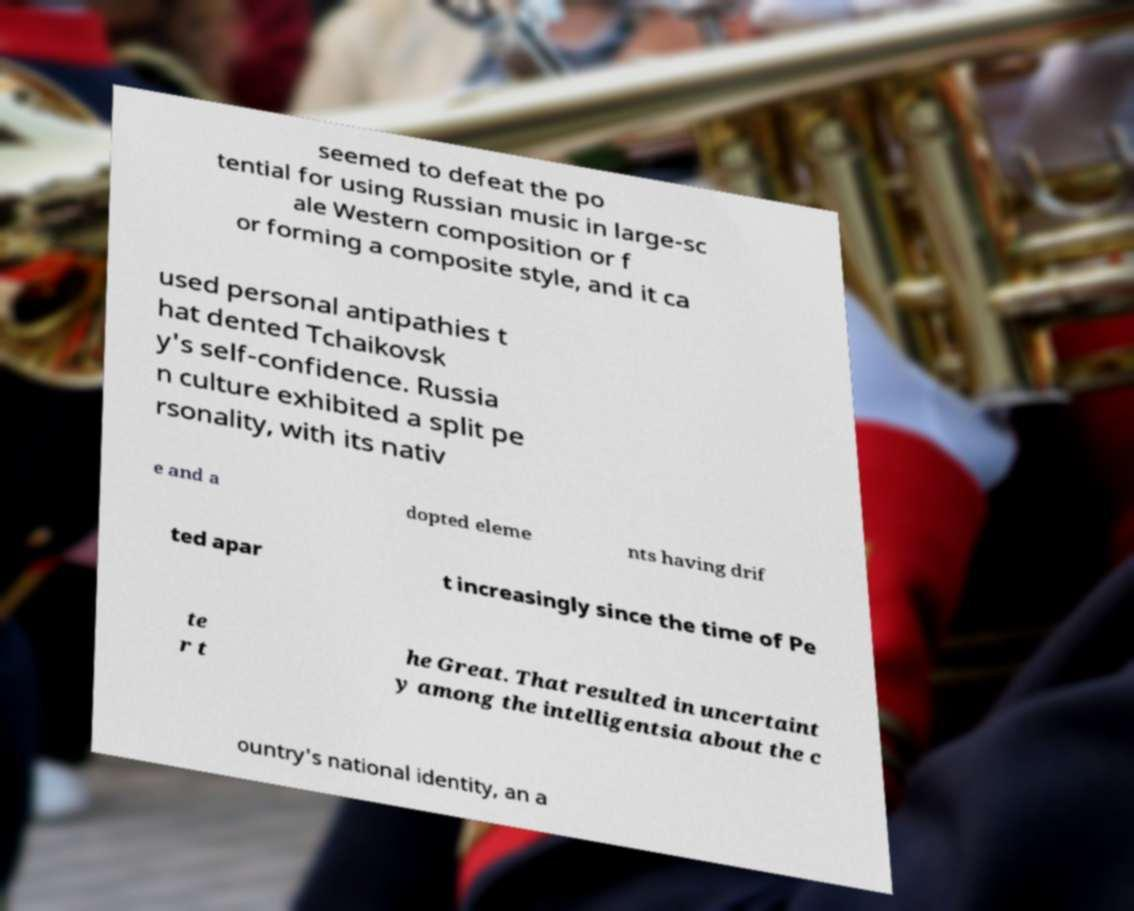Can you read and provide the text displayed in the image?This photo seems to have some interesting text. Can you extract and type it out for me? seemed to defeat the po tential for using Russian music in large-sc ale Western composition or f or forming a composite style, and it ca used personal antipathies t hat dented Tchaikovsk y's self-confidence. Russia n culture exhibited a split pe rsonality, with its nativ e and a dopted eleme nts having drif ted apar t increasingly since the time of Pe te r t he Great. That resulted in uncertaint y among the intelligentsia about the c ountry's national identity, an a 